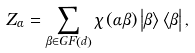Convert formula to latex. <formula><loc_0><loc_0><loc_500><loc_500>Z _ { \alpha } = \sum _ { \beta \in G F \left ( d \right ) } \chi \left ( \alpha \beta \right ) \left | \beta \right \rangle \left \langle \beta \right | ,</formula> 